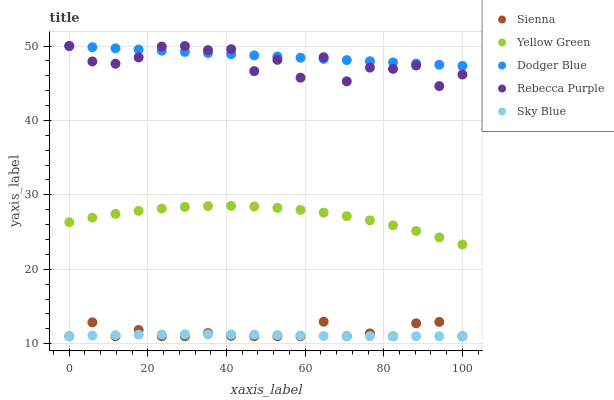Does Sky Blue have the minimum area under the curve?
Answer yes or no. Yes. Does Dodger Blue have the maximum area under the curve?
Answer yes or no. Yes. Does Dodger Blue have the minimum area under the curve?
Answer yes or no. No. Does Sky Blue have the maximum area under the curve?
Answer yes or no. No. Is Dodger Blue the smoothest?
Answer yes or no. Yes. Is Rebecca Purple the roughest?
Answer yes or no. Yes. Is Sky Blue the smoothest?
Answer yes or no. No. Is Sky Blue the roughest?
Answer yes or no. No. Does Sienna have the lowest value?
Answer yes or no. Yes. Does Dodger Blue have the lowest value?
Answer yes or no. No. Does Rebecca Purple have the highest value?
Answer yes or no. Yes. Does Sky Blue have the highest value?
Answer yes or no. No. Is Sky Blue less than Dodger Blue?
Answer yes or no. Yes. Is Dodger Blue greater than Sky Blue?
Answer yes or no. Yes. Does Sky Blue intersect Sienna?
Answer yes or no. Yes. Is Sky Blue less than Sienna?
Answer yes or no. No. Is Sky Blue greater than Sienna?
Answer yes or no. No. Does Sky Blue intersect Dodger Blue?
Answer yes or no. No. 